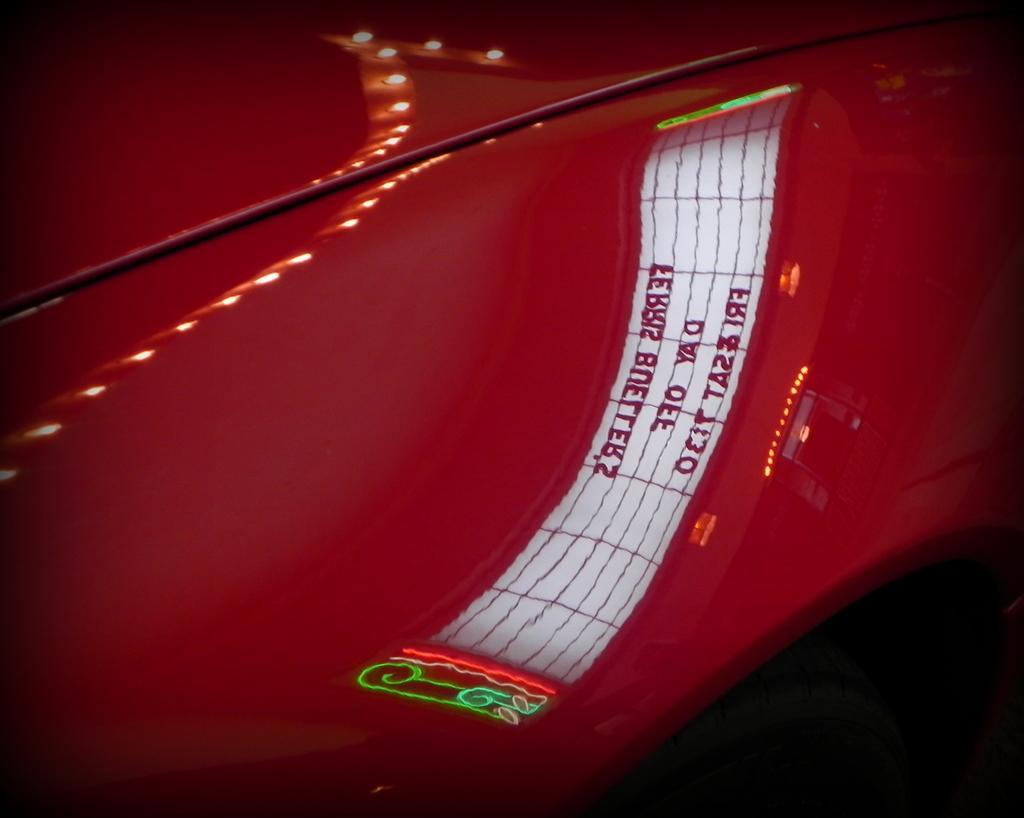In one or two sentences, can you explain what this image depicts? In this image there is a car which is red in colour with some reflection of the text reflecting on the car. 